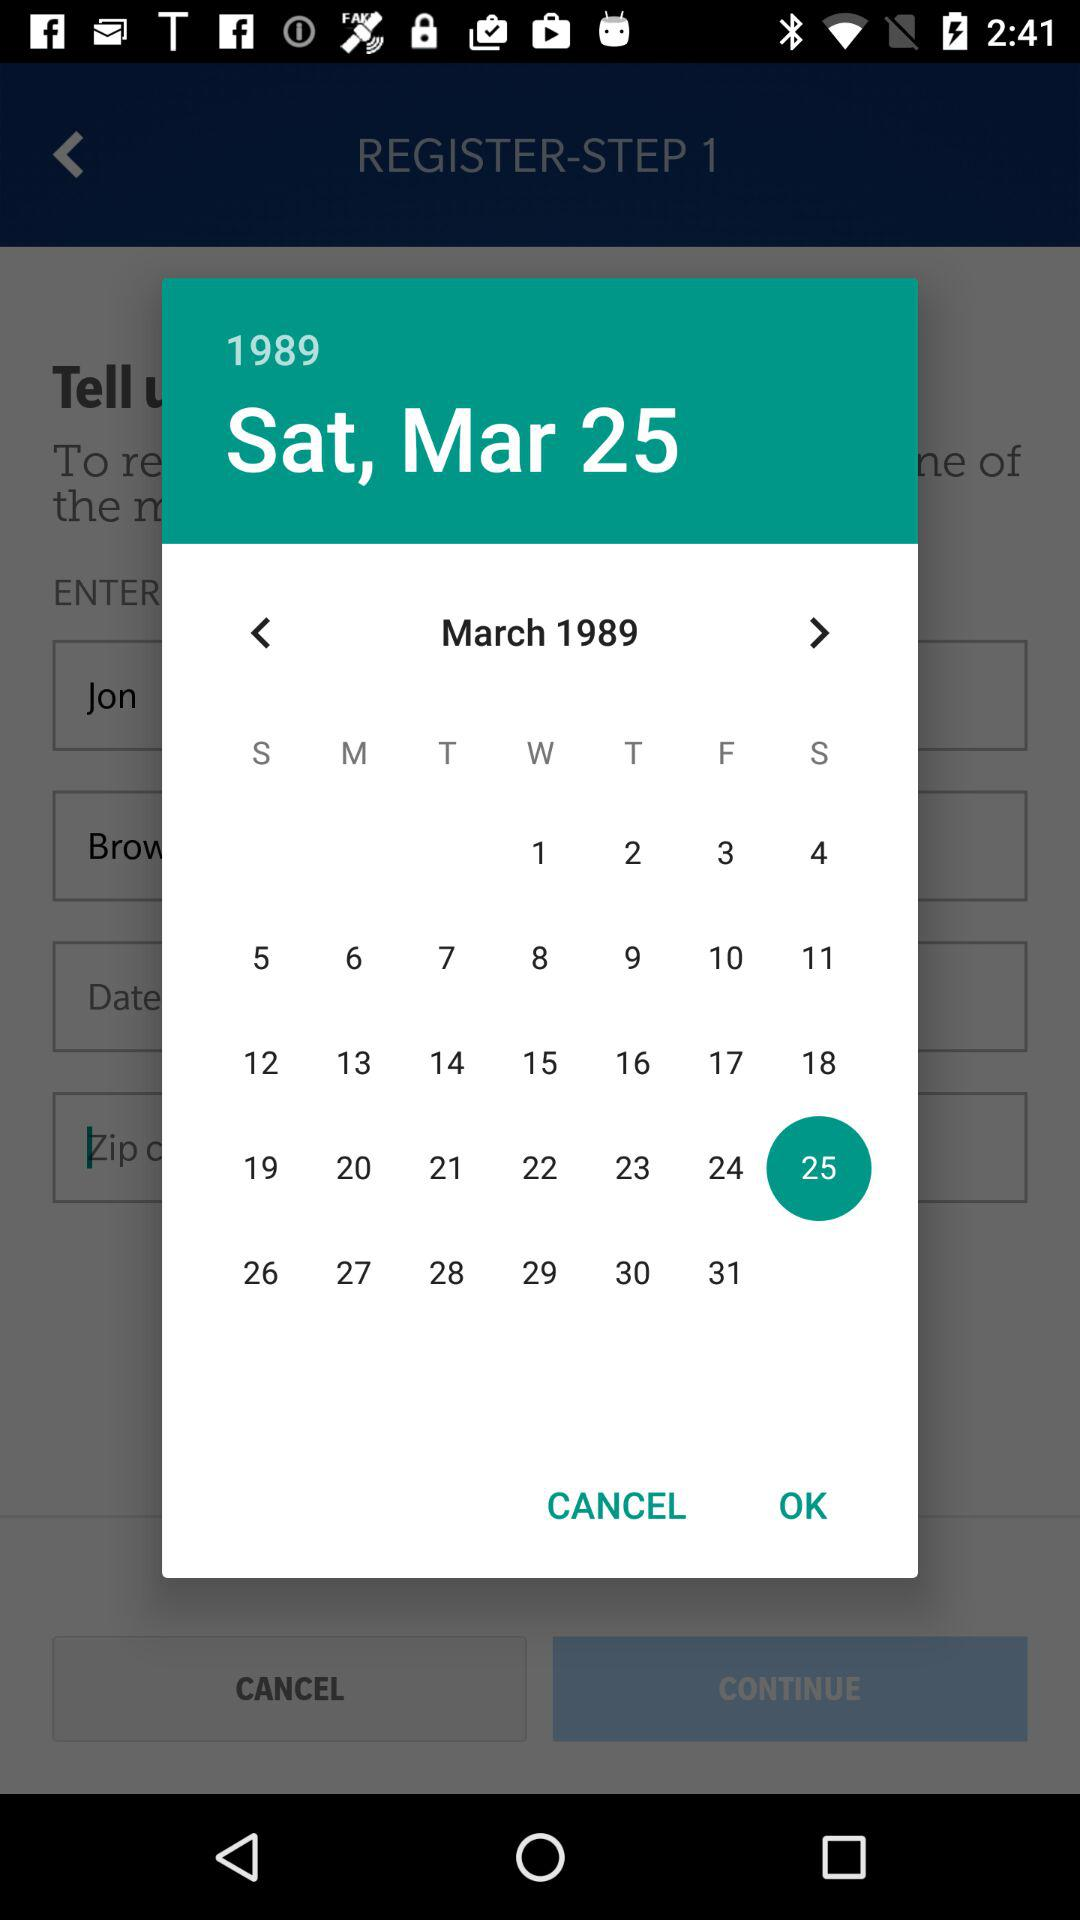What day is March 25th, 1989? The day is Saturday. 